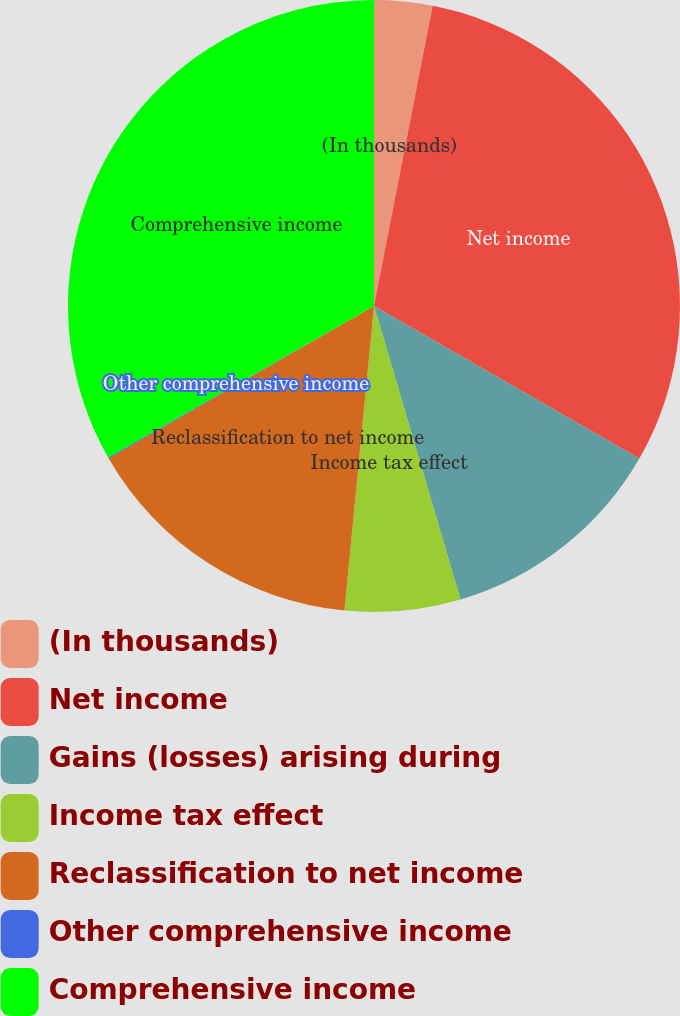Convert chart. <chart><loc_0><loc_0><loc_500><loc_500><pie_chart><fcel>(In thousands)<fcel>Net income<fcel>Gains (losses) arising during<fcel>Income tax effect<fcel>Reclassification to net income<fcel>Other comprehensive income<fcel>Comprehensive income<nl><fcel>3.07%<fcel>30.23%<fcel>12.14%<fcel>6.1%<fcel>15.16%<fcel>0.05%<fcel>33.25%<nl></chart> 